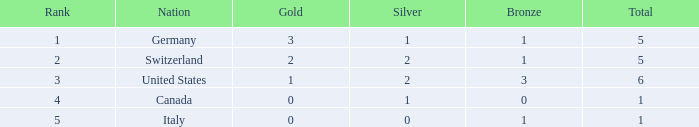How many golds for countries with more than 0 silvers, more than 1 total, and more than 3 bronzes? 0.0. 